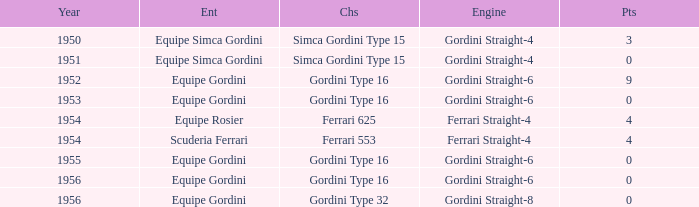How many points after 1956? 0.0. 